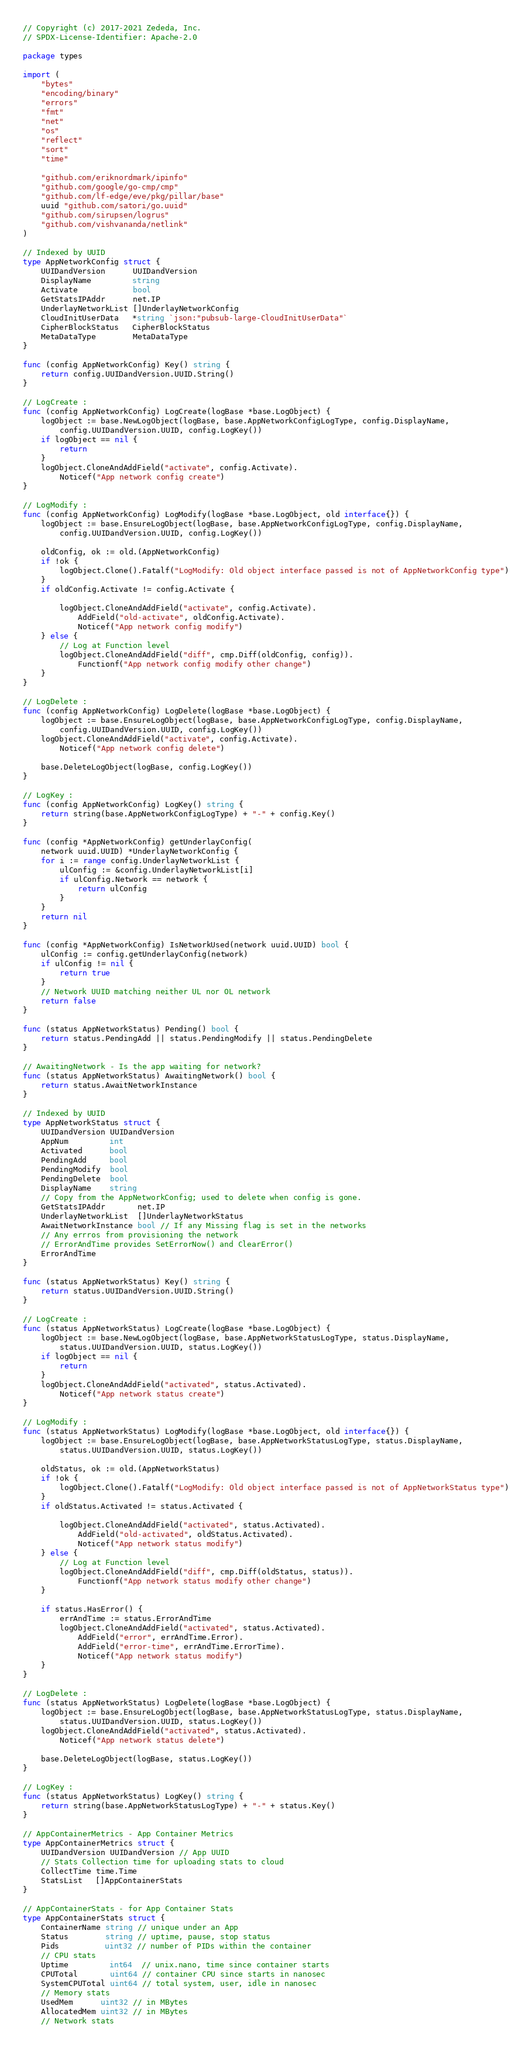<code> <loc_0><loc_0><loc_500><loc_500><_Go_>// Copyright (c) 2017-2021 Zededa, Inc.
// SPDX-License-Identifier: Apache-2.0

package types

import (
	"bytes"
	"encoding/binary"
	"errors"
	"fmt"
	"net"
	"os"
	"reflect"
	"sort"
	"time"

	"github.com/eriknordmark/ipinfo"
	"github.com/google/go-cmp/cmp"
	"github.com/lf-edge/eve/pkg/pillar/base"
	uuid "github.com/satori/go.uuid"
	"github.com/sirupsen/logrus"
	"github.com/vishvananda/netlink"
)

// Indexed by UUID
type AppNetworkConfig struct {
	UUIDandVersion      UUIDandVersion
	DisplayName         string
	Activate            bool
	GetStatsIPAddr      net.IP
	UnderlayNetworkList []UnderlayNetworkConfig
	CloudInitUserData   *string `json:"pubsub-large-CloudInitUserData"`
	CipherBlockStatus   CipherBlockStatus
	MetaDataType        MetaDataType
}

func (config AppNetworkConfig) Key() string {
	return config.UUIDandVersion.UUID.String()
}

// LogCreate :
func (config AppNetworkConfig) LogCreate(logBase *base.LogObject) {
	logObject := base.NewLogObject(logBase, base.AppNetworkConfigLogType, config.DisplayName,
		config.UUIDandVersion.UUID, config.LogKey())
	if logObject == nil {
		return
	}
	logObject.CloneAndAddField("activate", config.Activate).
		Noticef("App network config create")
}

// LogModify :
func (config AppNetworkConfig) LogModify(logBase *base.LogObject, old interface{}) {
	logObject := base.EnsureLogObject(logBase, base.AppNetworkConfigLogType, config.DisplayName,
		config.UUIDandVersion.UUID, config.LogKey())

	oldConfig, ok := old.(AppNetworkConfig)
	if !ok {
		logObject.Clone().Fatalf("LogModify: Old object interface passed is not of AppNetworkConfig type")
	}
	if oldConfig.Activate != config.Activate {

		logObject.CloneAndAddField("activate", config.Activate).
			AddField("old-activate", oldConfig.Activate).
			Noticef("App network config modify")
	} else {
		// Log at Function level
		logObject.CloneAndAddField("diff", cmp.Diff(oldConfig, config)).
			Functionf("App network config modify other change")
	}
}

// LogDelete :
func (config AppNetworkConfig) LogDelete(logBase *base.LogObject) {
	logObject := base.EnsureLogObject(logBase, base.AppNetworkConfigLogType, config.DisplayName,
		config.UUIDandVersion.UUID, config.LogKey())
	logObject.CloneAndAddField("activate", config.Activate).
		Noticef("App network config delete")

	base.DeleteLogObject(logBase, config.LogKey())
}

// LogKey :
func (config AppNetworkConfig) LogKey() string {
	return string(base.AppNetworkConfigLogType) + "-" + config.Key()
}

func (config *AppNetworkConfig) getUnderlayConfig(
	network uuid.UUID) *UnderlayNetworkConfig {
	for i := range config.UnderlayNetworkList {
		ulConfig := &config.UnderlayNetworkList[i]
		if ulConfig.Network == network {
			return ulConfig
		}
	}
	return nil
}

func (config *AppNetworkConfig) IsNetworkUsed(network uuid.UUID) bool {
	ulConfig := config.getUnderlayConfig(network)
	if ulConfig != nil {
		return true
	}
	// Network UUID matching neither UL nor OL network
	return false
}

func (status AppNetworkStatus) Pending() bool {
	return status.PendingAdd || status.PendingModify || status.PendingDelete
}

// AwaitingNetwork - Is the app waiting for network?
func (status AppNetworkStatus) AwaitingNetwork() bool {
	return status.AwaitNetworkInstance
}

// Indexed by UUID
type AppNetworkStatus struct {
	UUIDandVersion UUIDandVersion
	AppNum         int
	Activated      bool
	PendingAdd     bool
	PendingModify  bool
	PendingDelete  bool
	DisplayName    string
	// Copy from the AppNetworkConfig; used to delete when config is gone.
	GetStatsIPAddr       net.IP
	UnderlayNetworkList  []UnderlayNetworkStatus
	AwaitNetworkInstance bool // If any Missing flag is set in the networks
	// Any errros from provisioning the network
	// ErrorAndTime provides SetErrorNow() and ClearError()
	ErrorAndTime
}

func (status AppNetworkStatus) Key() string {
	return status.UUIDandVersion.UUID.String()
}

// LogCreate :
func (status AppNetworkStatus) LogCreate(logBase *base.LogObject) {
	logObject := base.NewLogObject(logBase, base.AppNetworkStatusLogType, status.DisplayName,
		status.UUIDandVersion.UUID, status.LogKey())
	if logObject == nil {
		return
	}
	logObject.CloneAndAddField("activated", status.Activated).
		Noticef("App network status create")
}

// LogModify :
func (status AppNetworkStatus) LogModify(logBase *base.LogObject, old interface{}) {
	logObject := base.EnsureLogObject(logBase, base.AppNetworkStatusLogType, status.DisplayName,
		status.UUIDandVersion.UUID, status.LogKey())

	oldStatus, ok := old.(AppNetworkStatus)
	if !ok {
		logObject.Clone().Fatalf("LogModify: Old object interface passed is not of AppNetworkStatus type")
	}
	if oldStatus.Activated != status.Activated {

		logObject.CloneAndAddField("activated", status.Activated).
			AddField("old-activated", oldStatus.Activated).
			Noticef("App network status modify")
	} else {
		// Log at Function level
		logObject.CloneAndAddField("diff", cmp.Diff(oldStatus, status)).
			Functionf("App network status modify other change")
	}

	if status.HasError() {
		errAndTime := status.ErrorAndTime
		logObject.CloneAndAddField("activated", status.Activated).
			AddField("error", errAndTime.Error).
			AddField("error-time", errAndTime.ErrorTime).
			Noticef("App network status modify")
	}
}

// LogDelete :
func (status AppNetworkStatus) LogDelete(logBase *base.LogObject) {
	logObject := base.EnsureLogObject(logBase, base.AppNetworkStatusLogType, status.DisplayName,
		status.UUIDandVersion.UUID, status.LogKey())
	logObject.CloneAndAddField("activated", status.Activated).
		Noticef("App network status delete")

	base.DeleteLogObject(logBase, status.LogKey())
}

// LogKey :
func (status AppNetworkStatus) LogKey() string {
	return string(base.AppNetworkStatusLogType) + "-" + status.Key()
}

// AppContainerMetrics - App Container Metrics
type AppContainerMetrics struct {
	UUIDandVersion UUIDandVersion // App UUID
	// Stats Collection time for uploading stats to cloud
	CollectTime time.Time
	StatsList   []AppContainerStats
}

// AppContainerStats - for App Container Stats
type AppContainerStats struct {
	ContainerName string // unique under an App
	Status        string // uptime, pause, stop status
	Pids          uint32 // number of PIDs within the container
	// CPU stats
	Uptime         int64  // unix.nano, time since container starts
	CPUTotal       uint64 // container CPU since starts in nanosec
	SystemCPUTotal uint64 // total system, user, idle in nanosec
	// Memory stats
	UsedMem      uint32 // in MBytes
	AllocatedMem uint32 // in MBytes
	// Network stats</code> 